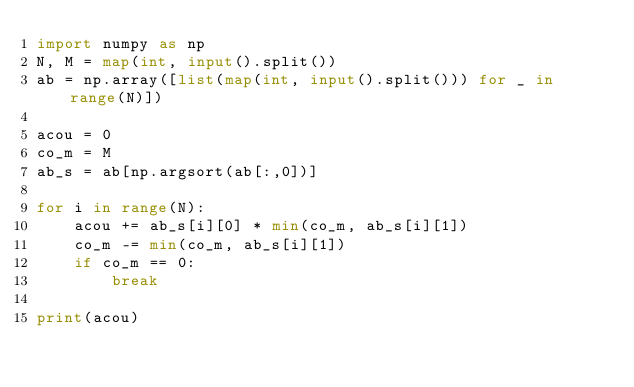Convert code to text. <code><loc_0><loc_0><loc_500><loc_500><_Python_>import numpy as np
N, M = map(int, input().split())
ab = np.array([list(map(int, input().split())) for _ in range(N)])

acou = 0
co_m = M
ab_s = ab[np.argsort(ab[:,0])]

for i in range(N):
    acou += ab_s[i][0] * min(co_m, ab_s[i][1])
    co_m -= min(co_m, ab_s[i][1])
    if co_m == 0:
        break

print(acou)</code> 